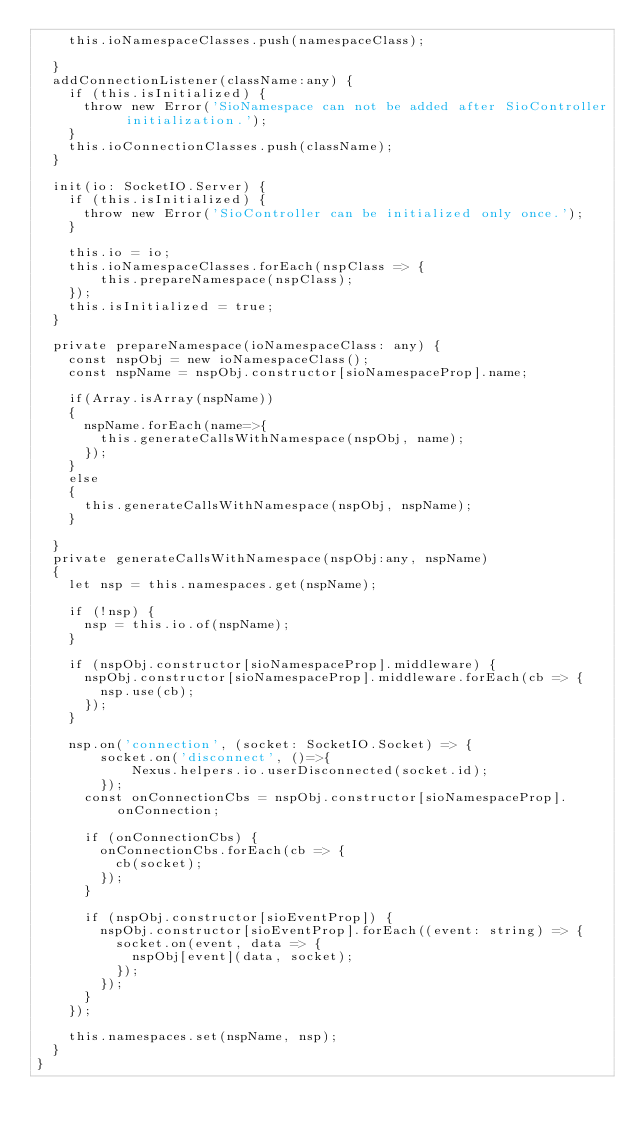Convert code to text. <code><loc_0><loc_0><loc_500><loc_500><_TypeScript_>    this.ioNamespaceClasses.push(namespaceClass);    
  
  }
  addConnectionListener(className:any) {
    if (this.isInitialized) {
      throw new Error('SioNamespace can not be added after SioController initialization.');
    }
    this.ioConnectionClasses.push(className);
  }

  init(io: SocketIO.Server) {
    if (this.isInitialized) {
      throw new Error('SioController can be initialized only once.');
    }

    this.io = io;
    this.ioNamespaceClasses.forEach(nspClass => {
        this.prepareNamespace(nspClass);
    });
    this.isInitialized = true;
  }

  private prepareNamespace(ioNamespaceClass: any) {
    const nspObj = new ioNamespaceClass();
    const nspName = nspObj.constructor[sioNamespaceProp].name;

    if(Array.isArray(nspName))
    {
      nspName.forEach(name=>{
        this.generateCallsWithNamespace(nspObj, name);
      });
    }
    else
    {
      this.generateCallsWithNamespace(nspObj, nspName);
    }
    
  }
  private generateCallsWithNamespace(nspObj:any, nspName)
  {
    let nsp = this.namespaces.get(nspName);

    if (!nsp) {
      nsp = this.io.of(nspName);
    }

    if (nspObj.constructor[sioNamespaceProp].middleware) {
      nspObj.constructor[sioNamespaceProp].middleware.forEach(cb => {
        nsp.use(cb);
      });
    }

    nsp.on('connection', (socket: SocketIO.Socket) => {
        socket.on('disconnect', ()=>{
            Nexus.helpers.io.userDisconnected(socket.id);
        });
      const onConnectionCbs = nspObj.constructor[sioNamespaceProp].onConnection;

      if (onConnectionCbs) {
        onConnectionCbs.forEach(cb => {
          cb(socket);
        });
      }

      if (nspObj.constructor[sioEventProp]) {
        nspObj.constructor[sioEventProp].forEach((event: string) => {
          socket.on(event, data => {
            nspObj[event](data, socket);
          });
        });
      }
    });

    this.namespaces.set(nspName, nsp);
  }
}
</code> 